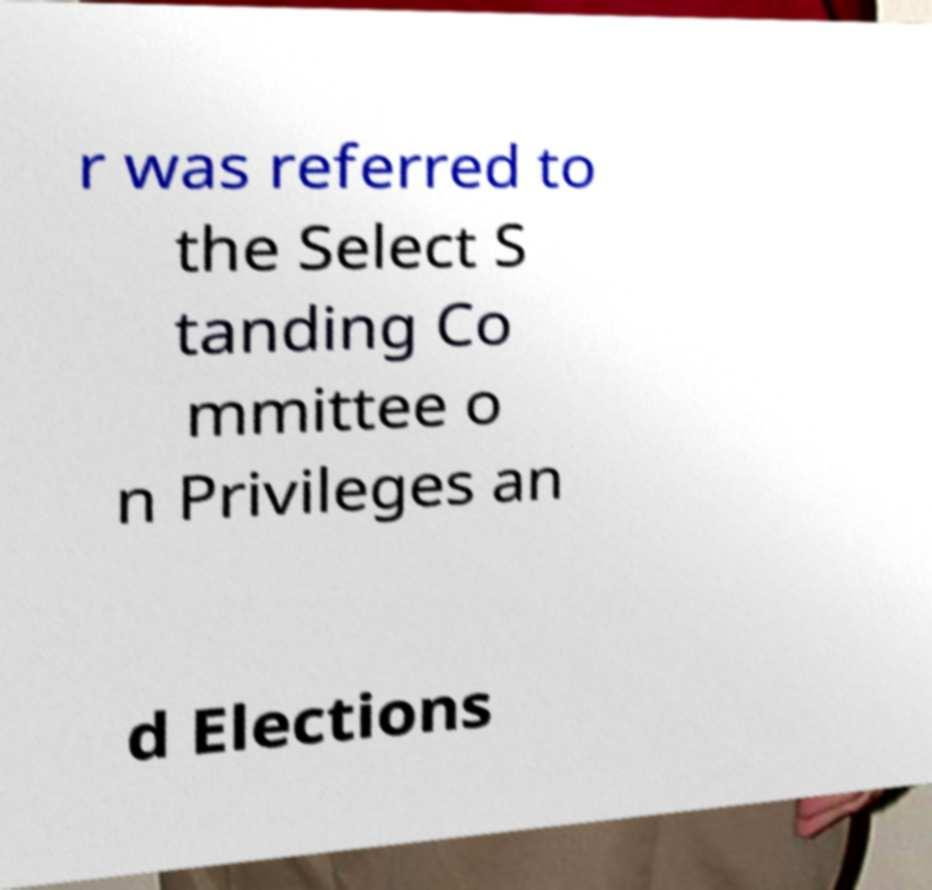What messages or text are displayed in this image? I need them in a readable, typed format. r was referred to the Select S tanding Co mmittee o n Privileges an d Elections 